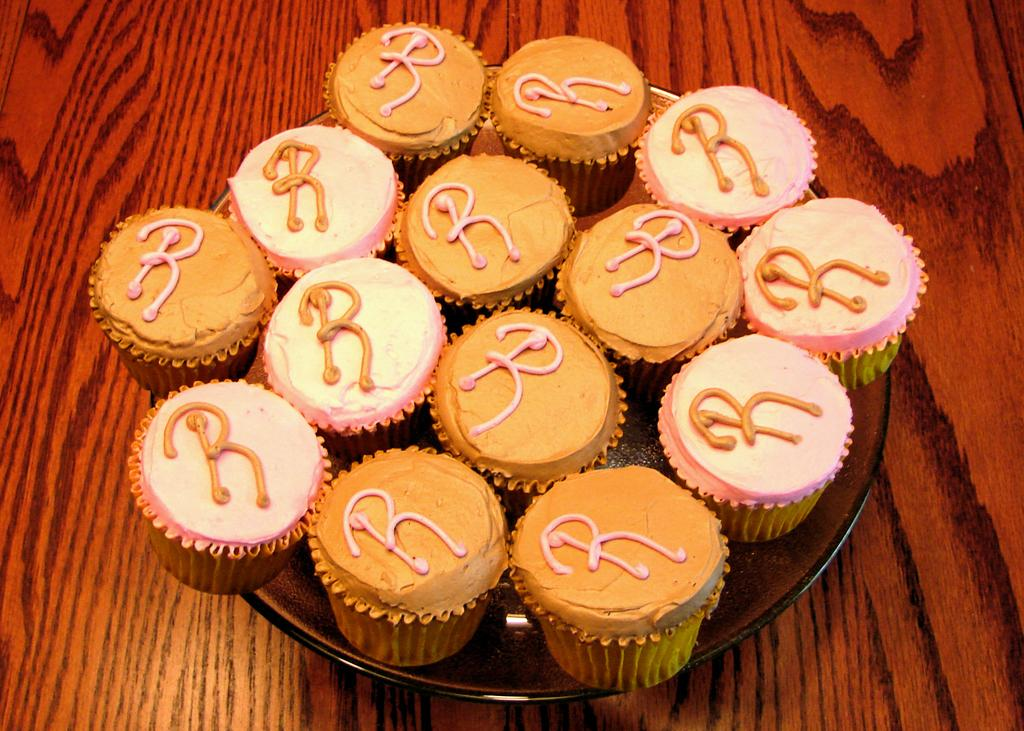What type of furniture is present in the image? There is a table in the image. What is placed on the table in the image? There is a plate on the table. What type of food is on the plate? There are cupcakes in the plate. What type of lace pattern can be seen on the cupcakes in the image? There is no lace pattern visible on the cupcakes in the image. How many ladybugs are crawling on the table in the image? There are no ladybugs present in the image. 